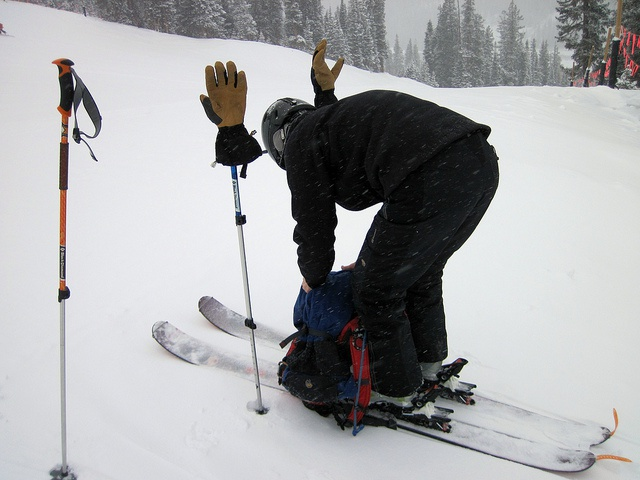Describe the objects in this image and their specific colors. I can see people in darkgray, black, gray, and white tones, backpack in darkgray, black, maroon, navy, and gray tones, skis in darkgray, lightgray, black, and gray tones, and skis in darkgray, lightgray, and gray tones in this image. 